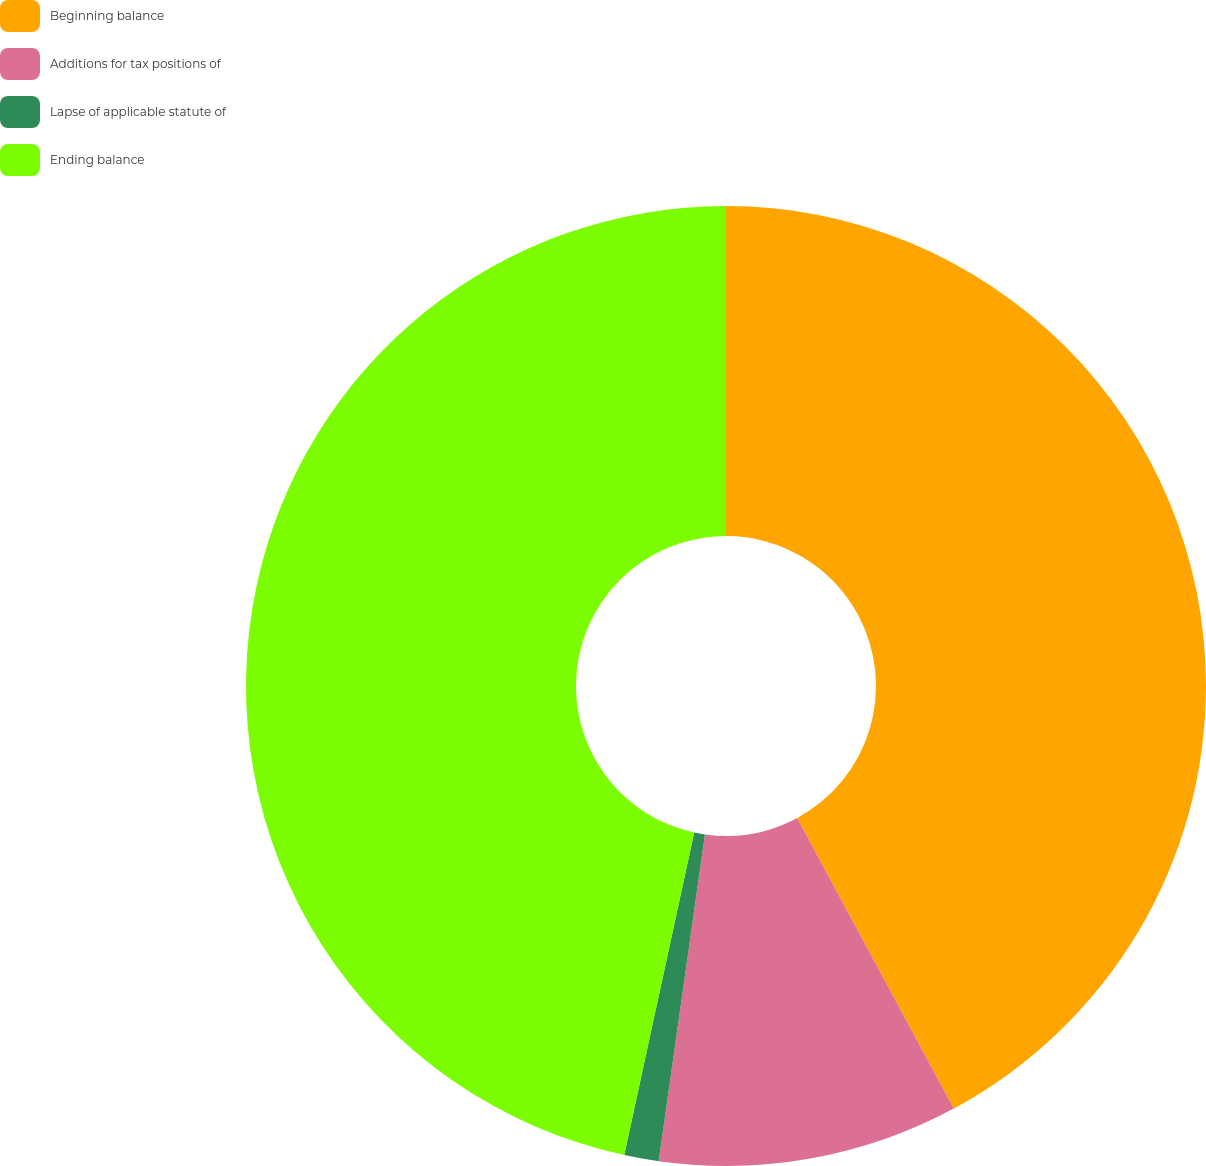Convert chart to OTSL. <chart><loc_0><loc_0><loc_500><loc_500><pie_chart><fcel>Beginning balance<fcel>Additions for tax positions of<fcel>Lapse of applicable statute of<fcel>Ending balance<nl><fcel>42.13%<fcel>10.11%<fcel>1.16%<fcel>46.6%<nl></chart> 